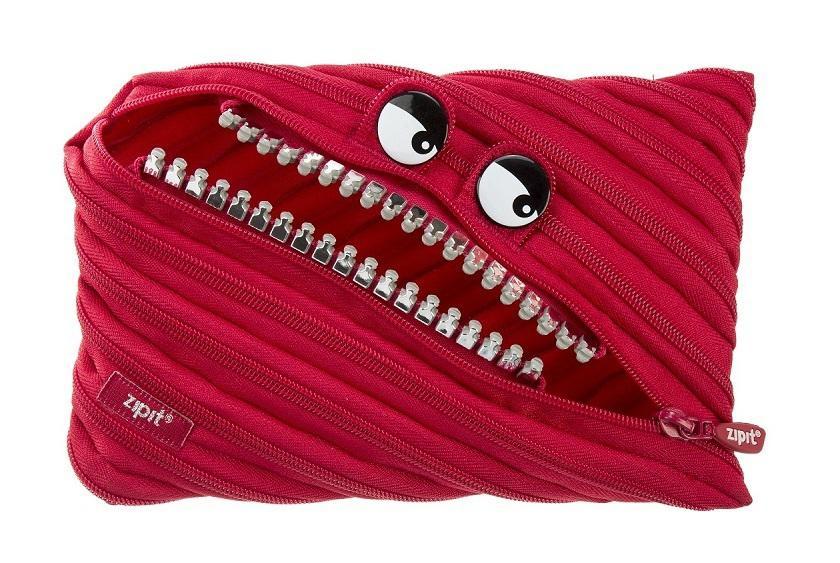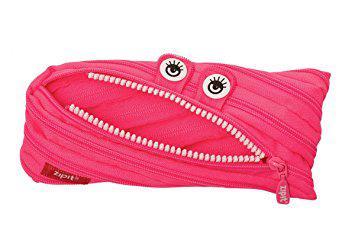The first image is the image on the left, the second image is the image on the right. Considering the images on both sides, is "One pouch is pink and the other pouch is red." valid? Answer yes or no. Yes. The first image is the image on the left, the second image is the image on the right. Evaluate the accuracy of this statement regarding the images: "At least one of the pouches has holes along the top to fit it into a three-ring binder.". Is it true? Answer yes or no. No. 